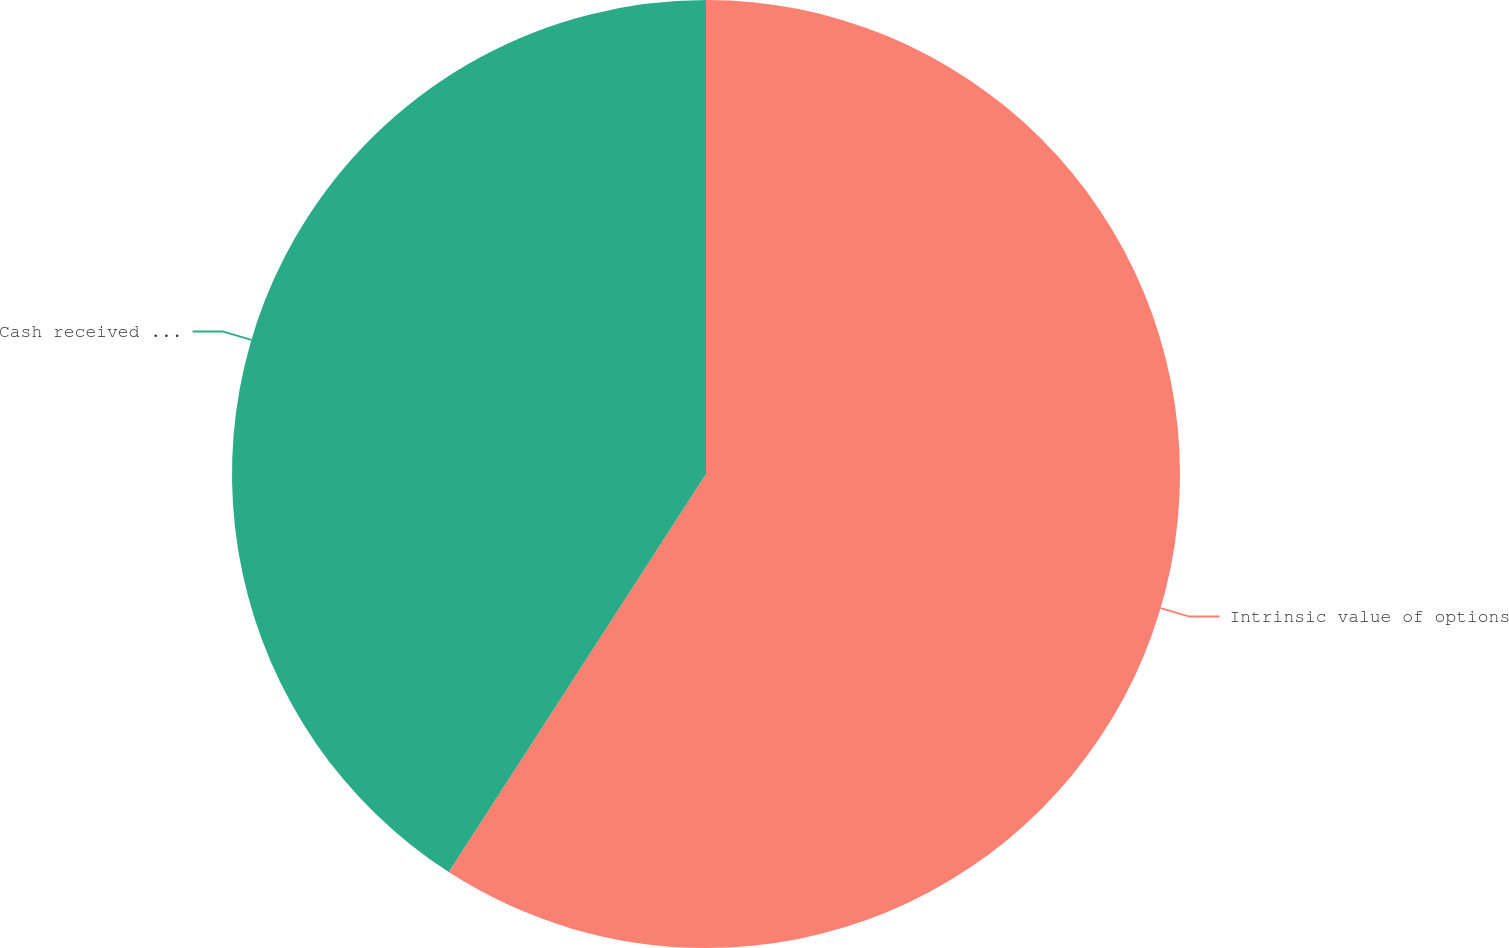Convert chart. <chart><loc_0><loc_0><loc_500><loc_500><pie_chart><fcel>Intrinsic value of options<fcel>Cash received from options<nl><fcel>59.13%<fcel>40.87%<nl></chart> 